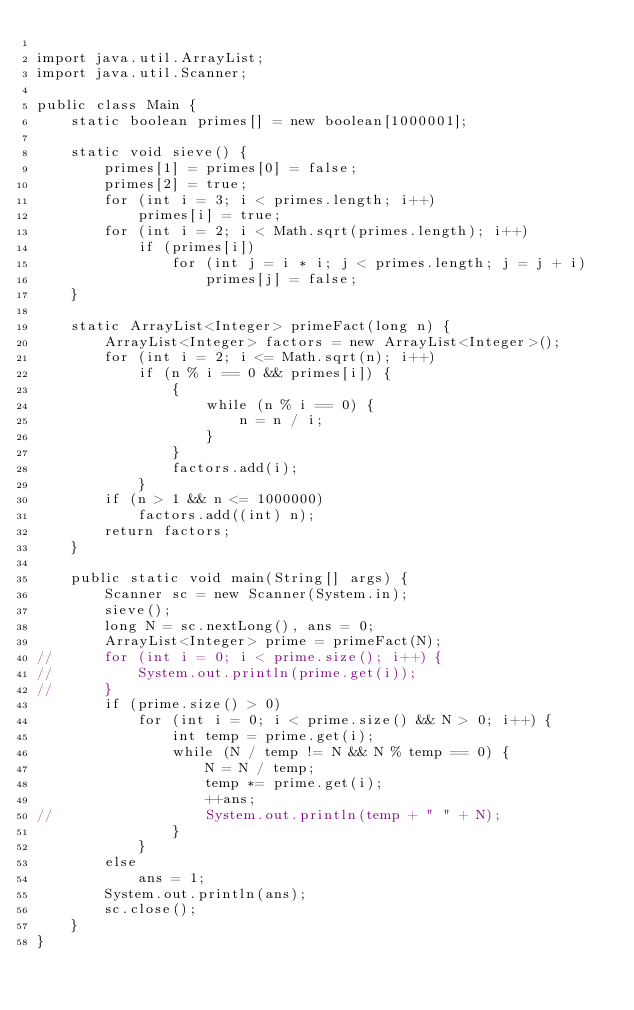Convert code to text. <code><loc_0><loc_0><loc_500><loc_500><_Java_>
import java.util.ArrayList;
import java.util.Scanner;

public class Main {
	static boolean primes[] = new boolean[1000001];

	static void sieve() {
		primes[1] = primes[0] = false;
		primes[2] = true;
		for (int i = 3; i < primes.length; i++)
			primes[i] = true;
		for (int i = 2; i < Math.sqrt(primes.length); i++)
			if (primes[i])
				for (int j = i * i; j < primes.length; j = j + i)
					primes[j] = false;
	}

	static ArrayList<Integer> primeFact(long n) {
		ArrayList<Integer> factors = new ArrayList<Integer>();
		for (int i = 2; i <= Math.sqrt(n); i++)
			if (n % i == 0 && primes[i]) {
				{
					while (n % i == 0) {
						n = n / i;
					}
				}
				factors.add(i);
			}
		if (n > 1 && n <= 1000000)
			factors.add((int) n);
		return factors;
	}

	public static void main(String[] args) {
		Scanner sc = new Scanner(System.in);
		sieve();
		long N = sc.nextLong(), ans = 0;
		ArrayList<Integer> prime = primeFact(N);
//		for (int i = 0; i < prime.size(); i++) {
//			System.out.println(prime.get(i));
//		}
		if (prime.size() > 0)
			for (int i = 0; i < prime.size() && N > 0; i++) {
				int temp = prime.get(i);
				while (N / temp != N && N % temp == 0) {
					N = N / temp;
					temp *= prime.get(i);
					++ans;
//					System.out.println(temp + " " + N);
				}
			}
		else
			ans = 1;
		System.out.println(ans);
		sc.close();
	}
}
</code> 